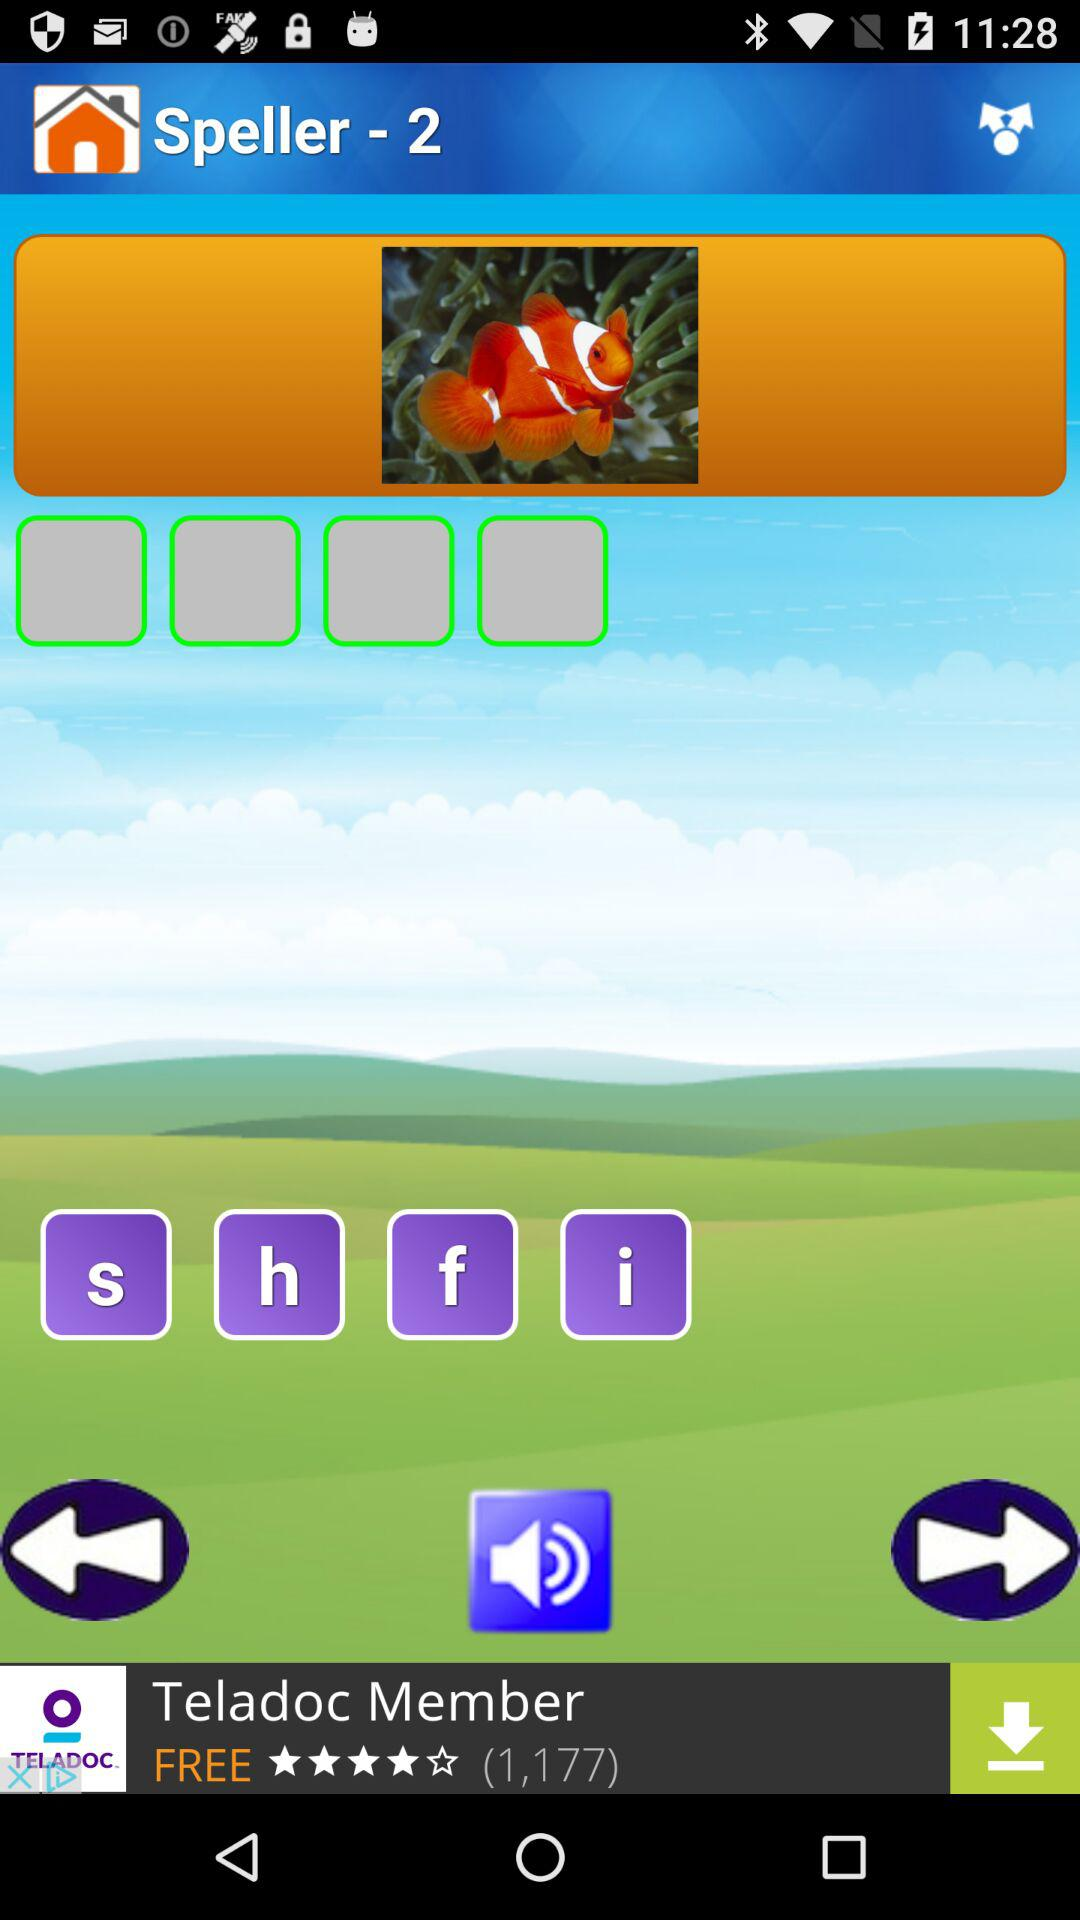Through which applications can this be shared?
When the provided information is insufficient, respond with <no answer>. <no answer> 